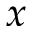<formula> <loc_0><loc_0><loc_500><loc_500>x</formula> 